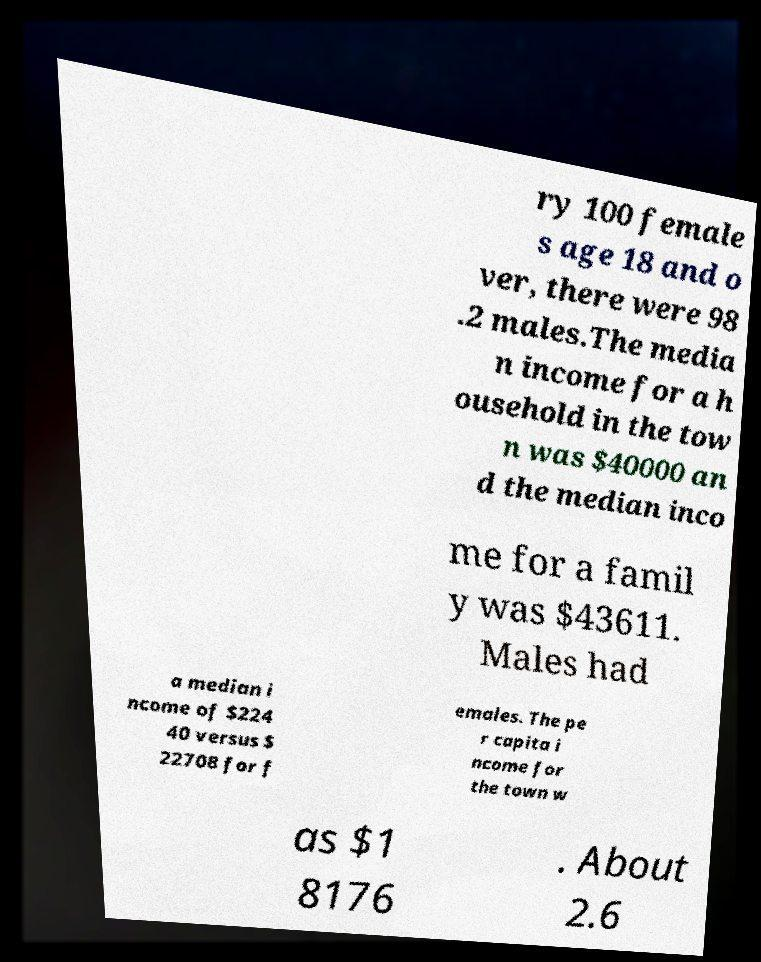Can you read and provide the text displayed in the image?This photo seems to have some interesting text. Can you extract and type it out for me? ry 100 female s age 18 and o ver, there were 98 .2 males.The media n income for a h ousehold in the tow n was $40000 an d the median inco me for a famil y was $43611. Males had a median i ncome of $224 40 versus $ 22708 for f emales. The pe r capita i ncome for the town w as $1 8176 . About 2.6 